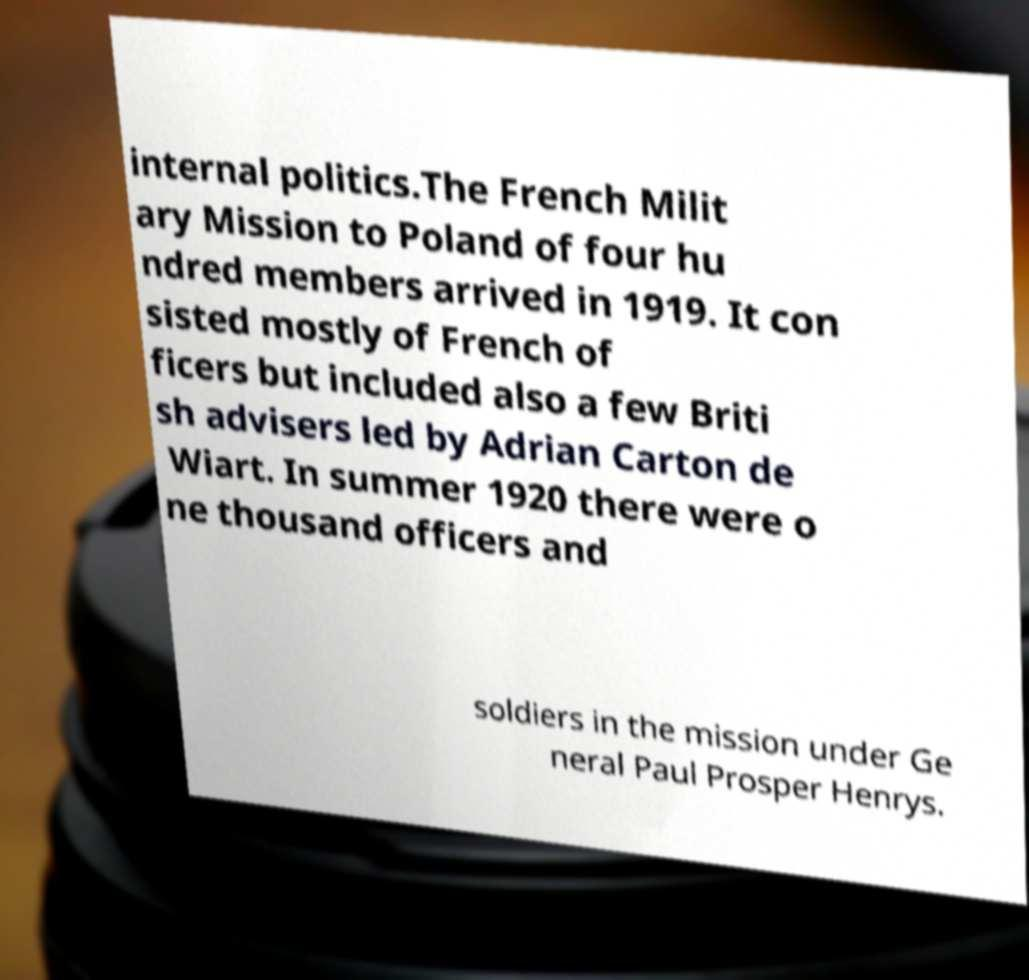I need the written content from this picture converted into text. Can you do that? internal politics.The French Milit ary Mission to Poland of four hu ndred members arrived in 1919. It con sisted mostly of French of ficers but included also a few Briti sh advisers led by Adrian Carton de Wiart. In summer 1920 there were o ne thousand officers and soldiers in the mission under Ge neral Paul Prosper Henrys. 